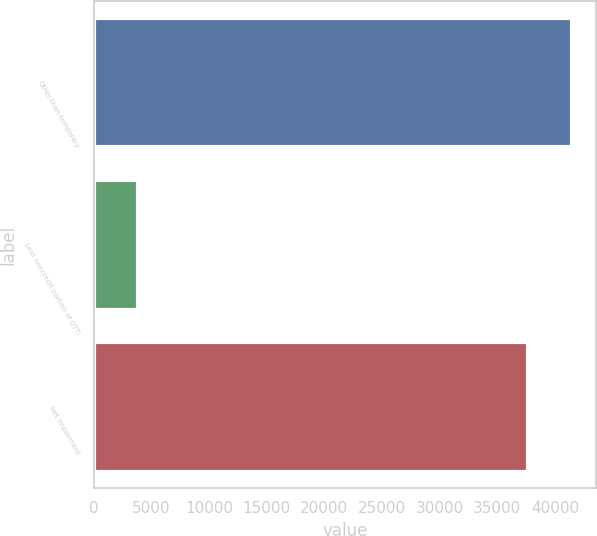Convert chart. <chart><loc_0><loc_0><loc_500><loc_500><bar_chart><fcel>Other-than-temporary<fcel>Less noncredit portion of OTTI<fcel>Net impairment<nl><fcel>41510<fcel>3840<fcel>37670<nl></chart> 